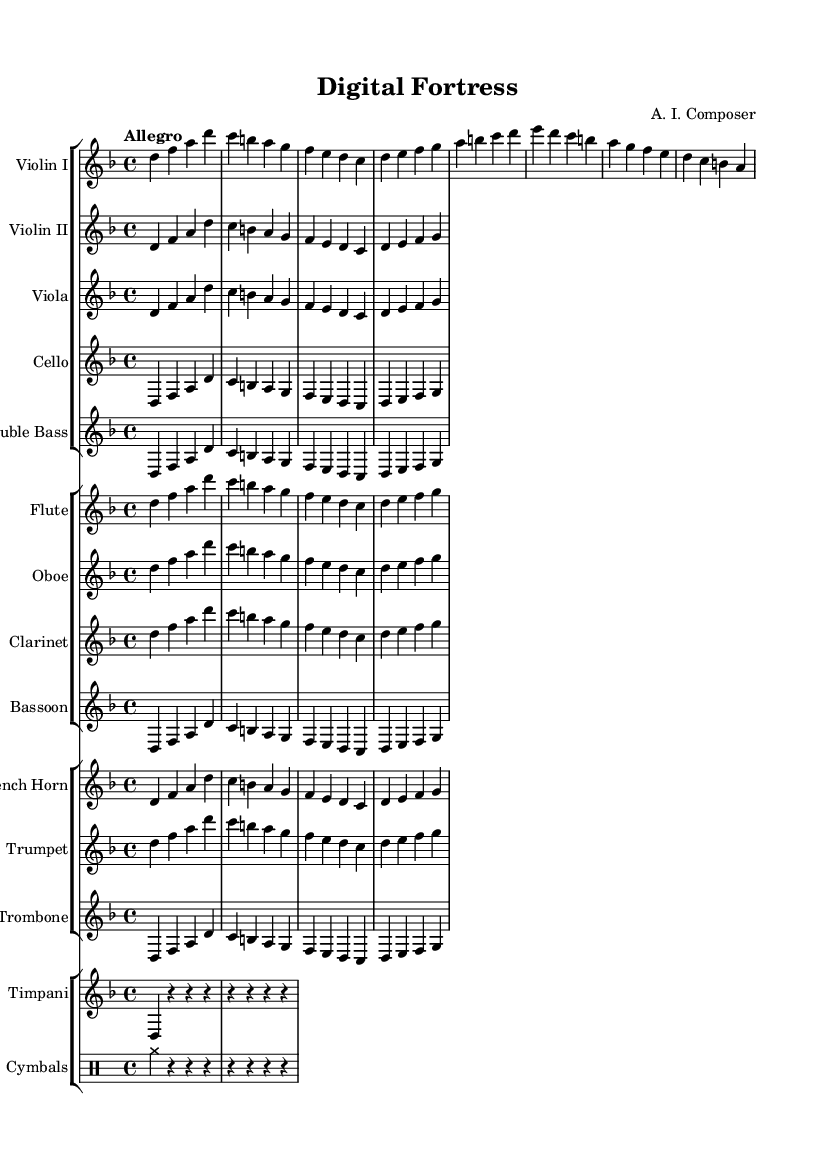What is the key signature of this music? The key signature indicated in the music sheet is D minor, which has one flat (B flat). This can be identified from the beginning of the sheet music where the key is typically stated.
Answer: D minor What is the time signature of this music? The time signature displayed at the beginning of the score is 4/4. This indicates that there are four beats in each measure, and each quarter note gets one beat. This is shown immediately after the key signature.
Answer: 4/4 What is the tempo marking of this music? The tempo marking at the beginning states "Allegro," which informs the performers to play at a fast and lively pace. It is typically placed above the staff early in the sheet music.
Answer: Allegro How many violins are there in this symphony? There are two violin parts notated in the score, with one designated as "Violin I" and the other as "Violin II." This can be seen in the staff grouping where both violins are listed.
Answer: Two What instruments are included in this symphony? The instruments listed in the score include Violin I, Violin II, Viola, Cello, Double Bass, Flute, Oboe, Clarinet, Bassoon, French Horn, Trumpet, Trombone, Timpani, and Cymbals. This can be deduced from the staff groupings arranged for different sections in the music.
Answer: Twelve Which instrument plays a rhythmic role apart from the melody? The instrument that primarily provides rhythmic support in this score is the Timpani, which is represented by rest notes and emphasizes the beat in this piece. Timpani often plays a foundational role in orchestral music, and its part can be observed in the percussion section of the score.
Answer: Timpani 